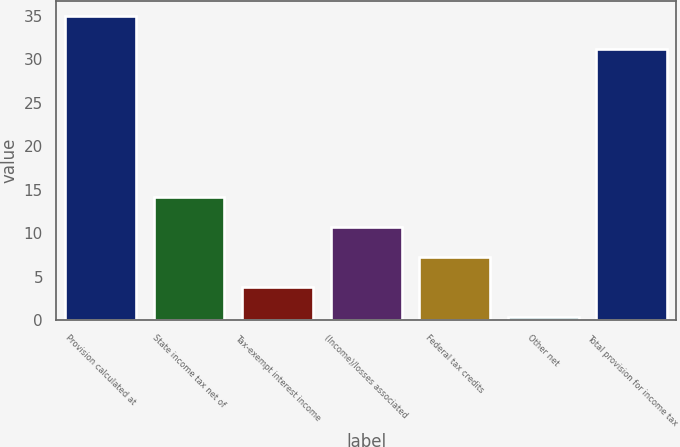<chart> <loc_0><loc_0><loc_500><loc_500><bar_chart><fcel>Provision calculated at<fcel>State income tax net of<fcel>Tax-exempt interest income<fcel>(Income)/losses associated<fcel>Federal tax credits<fcel>Other net<fcel>Total provision for income tax<nl><fcel>35<fcel>14.18<fcel>3.77<fcel>10.71<fcel>7.24<fcel>0.3<fcel>31.2<nl></chart> 